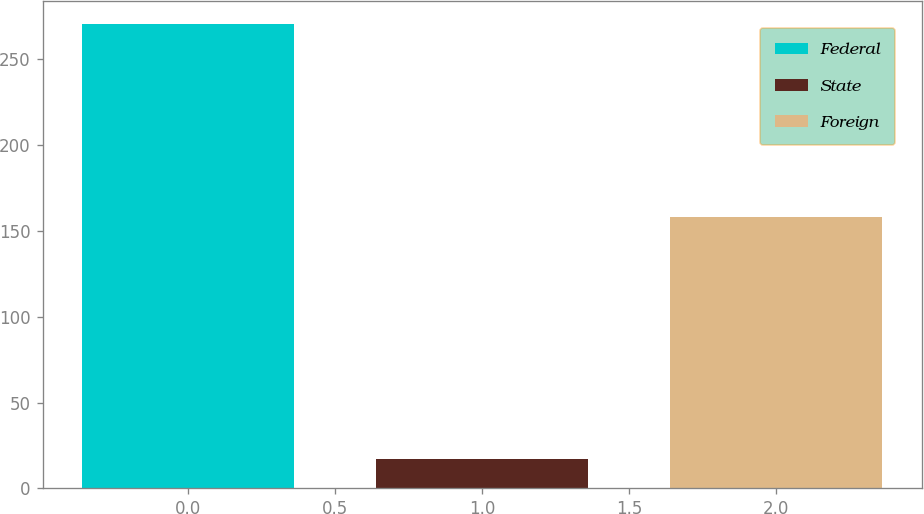<chart> <loc_0><loc_0><loc_500><loc_500><bar_chart><fcel>Federal<fcel>State<fcel>Foreign<nl><fcel>270<fcel>17<fcel>158<nl></chart> 